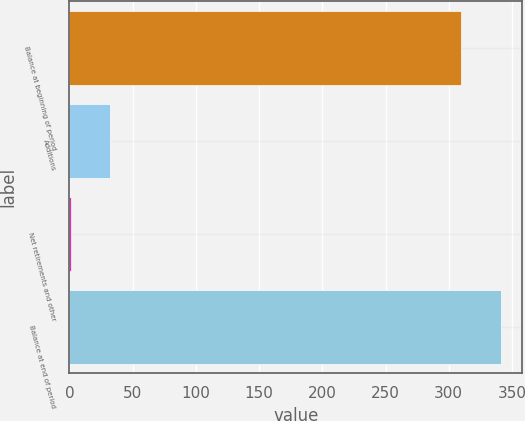<chart> <loc_0><loc_0><loc_500><loc_500><bar_chart><fcel>Balance at beginning of period<fcel>Additions<fcel>Net retirements and other<fcel>Balance at end of period<nl><fcel>310<fcel>32.1<fcel>1<fcel>341.1<nl></chart> 